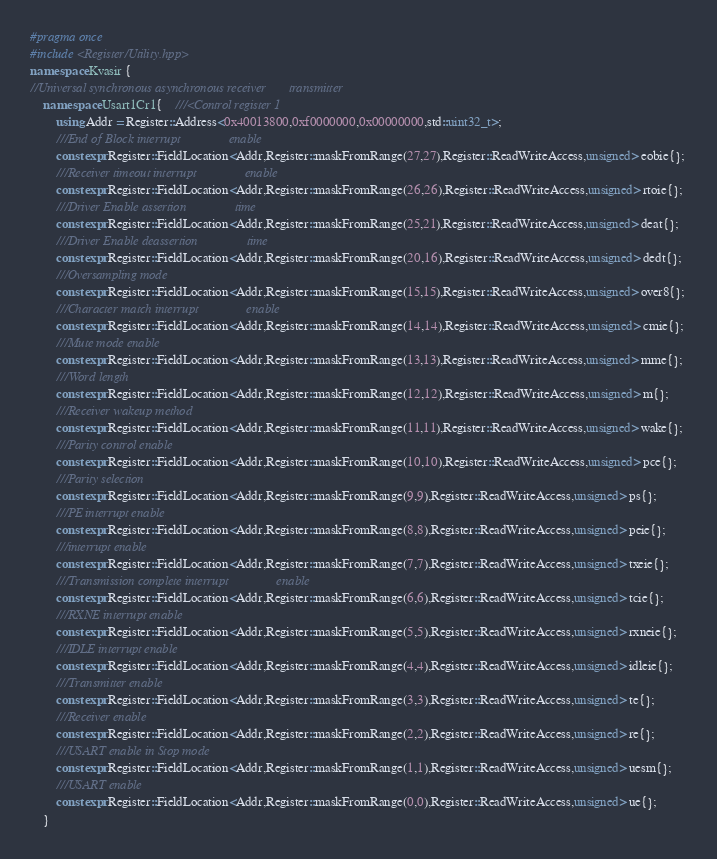Convert code to text. <code><loc_0><loc_0><loc_500><loc_500><_C++_>#pragma once 
#include <Register/Utility.hpp>
namespace Kvasir {
//Universal synchronous asynchronous receiver       transmitter
    namespace Usart1Cr1{    ///<Control register 1
        using Addr = Register::Address<0x40013800,0xf0000000,0x00000000,std::uint32_t>;
        ///End of Block interrupt               enable
        constexpr Register::FieldLocation<Addr,Register::maskFromRange(27,27),Register::ReadWriteAccess,unsigned> eobie{}; 
        ///Receiver timeout interrupt               enable
        constexpr Register::FieldLocation<Addr,Register::maskFromRange(26,26),Register::ReadWriteAccess,unsigned> rtoie{}; 
        ///Driver Enable assertion               time
        constexpr Register::FieldLocation<Addr,Register::maskFromRange(25,21),Register::ReadWriteAccess,unsigned> deat{}; 
        ///Driver Enable deassertion               time
        constexpr Register::FieldLocation<Addr,Register::maskFromRange(20,16),Register::ReadWriteAccess,unsigned> dedt{}; 
        ///Oversampling mode
        constexpr Register::FieldLocation<Addr,Register::maskFromRange(15,15),Register::ReadWriteAccess,unsigned> over8{}; 
        ///Character match interrupt               enable
        constexpr Register::FieldLocation<Addr,Register::maskFromRange(14,14),Register::ReadWriteAccess,unsigned> cmie{}; 
        ///Mute mode enable
        constexpr Register::FieldLocation<Addr,Register::maskFromRange(13,13),Register::ReadWriteAccess,unsigned> mme{}; 
        ///Word length
        constexpr Register::FieldLocation<Addr,Register::maskFromRange(12,12),Register::ReadWriteAccess,unsigned> m{}; 
        ///Receiver wakeup method
        constexpr Register::FieldLocation<Addr,Register::maskFromRange(11,11),Register::ReadWriteAccess,unsigned> wake{}; 
        ///Parity control enable
        constexpr Register::FieldLocation<Addr,Register::maskFromRange(10,10),Register::ReadWriteAccess,unsigned> pce{}; 
        ///Parity selection
        constexpr Register::FieldLocation<Addr,Register::maskFromRange(9,9),Register::ReadWriteAccess,unsigned> ps{}; 
        ///PE interrupt enable
        constexpr Register::FieldLocation<Addr,Register::maskFromRange(8,8),Register::ReadWriteAccess,unsigned> peie{}; 
        ///interrupt enable
        constexpr Register::FieldLocation<Addr,Register::maskFromRange(7,7),Register::ReadWriteAccess,unsigned> txeie{}; 
        ///Transmission complete interrupt               enable
        constexpr Register::FieldLocation<Addr,Register::maskFromRange(6,6),Register::ReadWriteAccess,unsigned> tcie{}; 
        ///RXNE interrupt enable
        constexpr Register::FieldLocation<Addr,Register::maskFromRange(5,5),Register::ReadWriteAccess,unsigned> rxneie{}; 
        ///IDLE interrupt enable
        constexpr Register::FieldLocation<Addr,Register::maskFromRange(4,4),Register::ReadWriteAccess,unsigned> idleie{}; 
        ///Transmitter enable
        constexpr Register::FieldLocation<Addr,Register::maskFromRange(3,3),Register::ReadWriteAccess,unsigned> te{}; 
        ///Receiver enable
        constexpr Register::FieldLocation<Addr,Register::maskFromRange(2,2),Register::ReadWriteAccess,unsigned> re{}; 
        ///USART enable in Stop mode
        constexpr Register::FieldLocation<Addr,Register::maskFromRange(1,1),Register::ReadWriteAccess,unsigned> uesm{}; 
        ///USART enable
        constexpr Register::FieldLocation<Addr,Register::maskFromRange(0,0),Register::ReadWriteAccess,unsigned> ue{}; 
    }</code> 